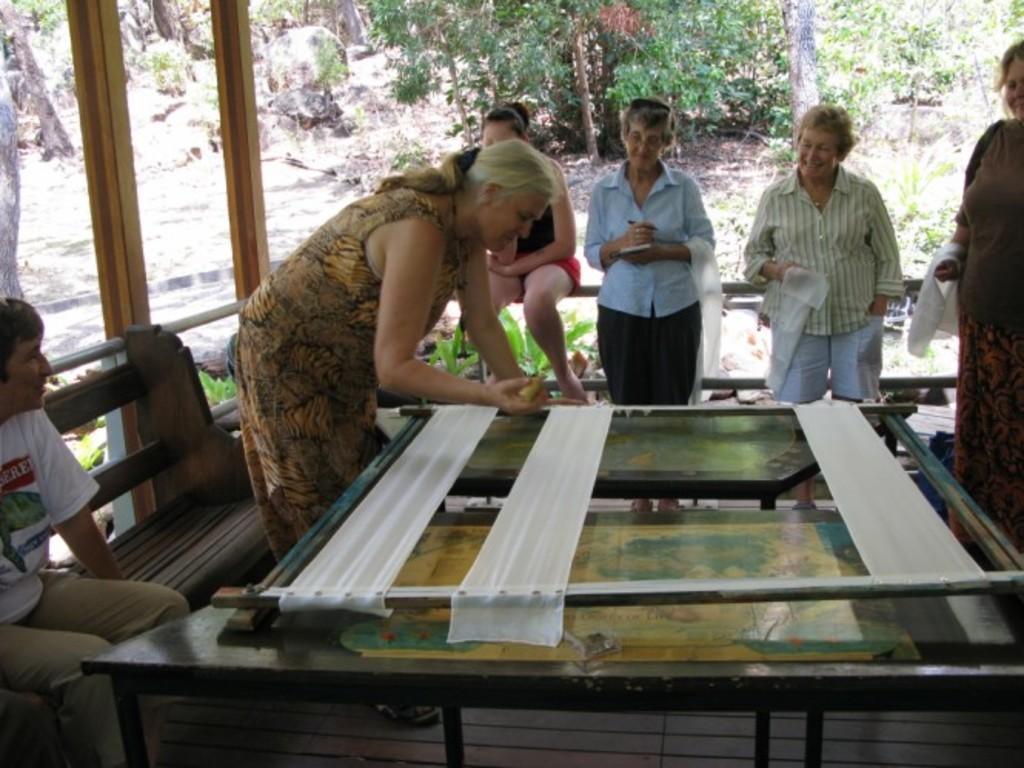How would you summarize this image in a sentence or two? There are many people standing in this picture. Two of them were sitting. Woman is standing in front of a table is working on something with her hand. In the background, there are some trees and rock here. 